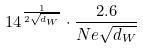<formula> <loc_0><loc_0><loc_500><loc_500>1 4 ^ { \frac { 1 } { 2 \sqrt { d _ { W } } } } \cdot \frac { 2 . 6 } { N e \sqrt { d _ { W } } }</formula> 